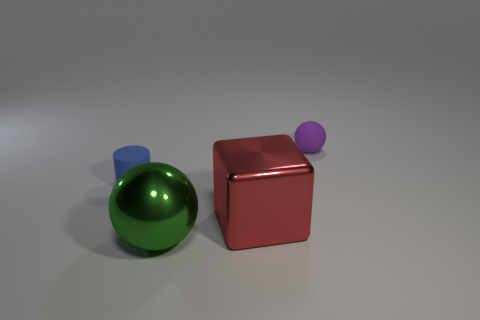Is the number of red metallic cubes in front of the red metal block greater than the number of green shiny spheres that are behind the big green metal object?
Give a very brief answer. No. Do the ball in front of the rubber ball and the small purple thing have the same material?
Offer a very short reply. No. What is the shape of the tiny purple object?
Your answer should be very brief. Sphere. Is the number of large metallic spheres that are behind the big red metallic block greater than the number of large yellow cubes?
Keep it short and to the point. No. Are there any other things that have the same shape as the large red thing?
Your answer should be compact. No. What color is the small object that is the same shape as the big green thing?
Give a very brief answer. Purple. What shape is the tiny matte thing behind the cylinder?
Provide a short and direct response. Sphere. There is a tiny purple rubber ball; are there any metallic cubes behind it?
Ensure brevity in your answer.  No. Is there anything else that is the same size as the cylinder?
Your response must be concise. Yes. There is a thing that is made of the same material as the big red block; what is its color?
Your answer should be compact. Green. 